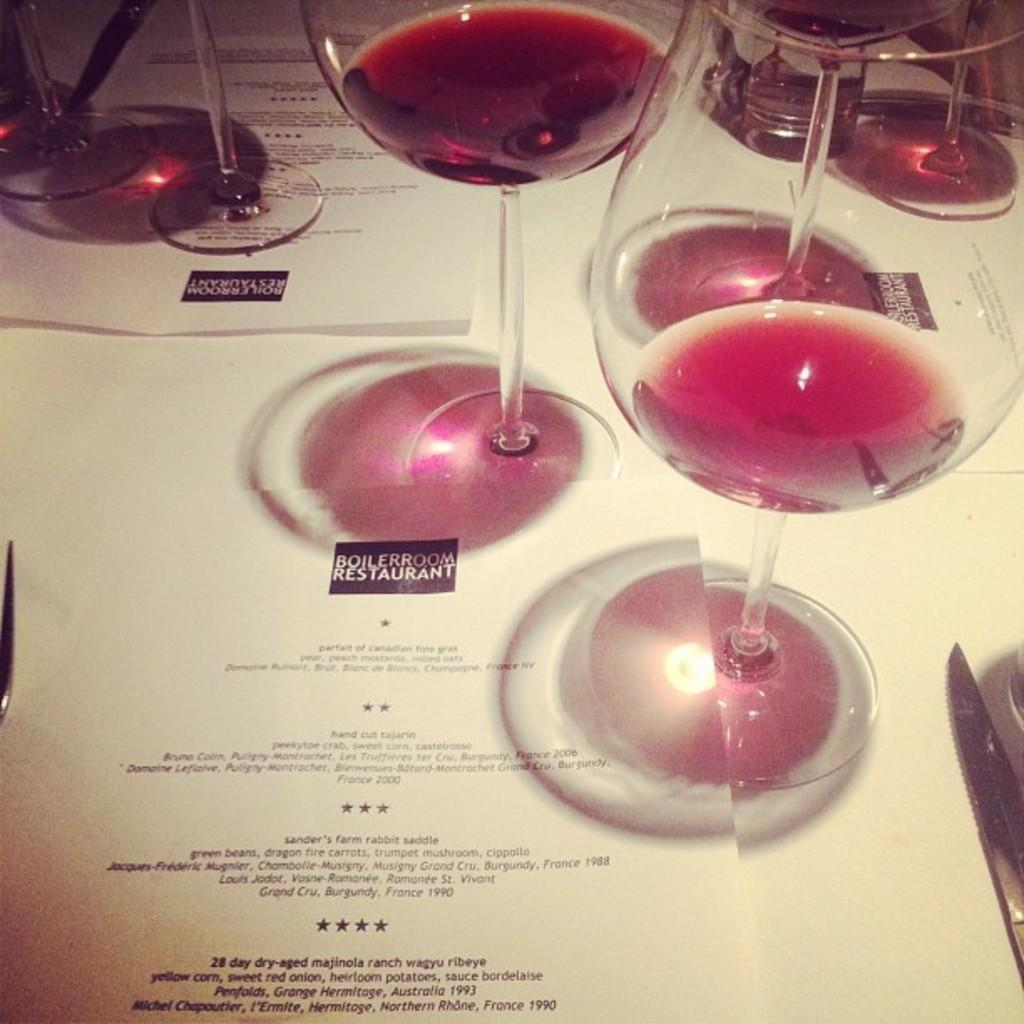What objects are on the table in the image? There are glasses on a table in the image. Where is the table located in the image? The table is in the center of the image. Reasoning: Let' Let's think step by step in order to produce the conversation. We start by identifying the main objects in the image, which are the glasses on the table. Then, we describe the location of the table, which is in the center of the image. Each question is designed to elicit a specific detail about the image that is known from the provided facts. Absurd Question/Answer: What is the value of the copper coins on the table in the image? There are no copper coins present in the image; only glasses are visible on the table. 